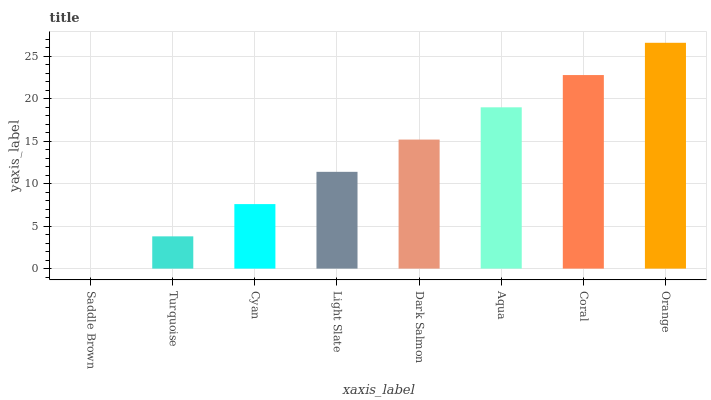Is Saddle Brown the minimum?
Answer yes or no. Yes. Is Orange the maximum?
Answer yes or no. Yes. Is Turquoise the minimum?
Answer yes or no. No. Is Turquoise the maximum?
Answer yes or no. No. Is Turquoise greater than Saddle Brown?
Answer yes or no. Yes. Is Saddle Brown less than Turquoise?
Answer yes or no. Yes. Is Saddle Brown greater than Turquoise?
Answer yes or no. No. Is Turquoise less than Saddle Brown?
Answer yes or no. No. Is Dark Salmon the high median?
Answer yes or no. Yes. Is Light Slate the low median?
Answer yes or no. Yes. Is Coral the high median?
Answer yes or no. No. Is Orange the low median?
Answer yes or no. No. 